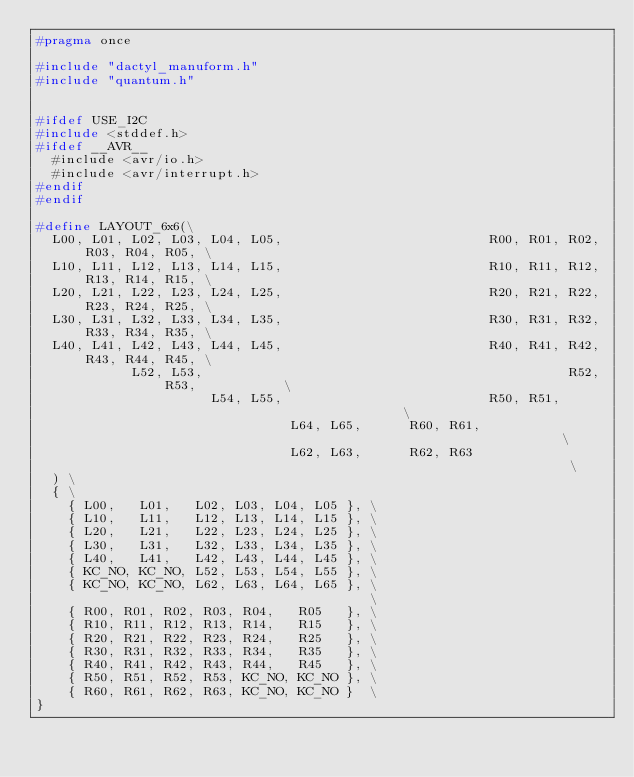<code> <loc_0><loc_0><loc_500><loc_500><_C_>#pragma once

#include "dactyl_manuform.h"
#include "quantum.h"


#ifdef USE_I2C
#include <stddef.h>
#ifdef __AVR__
  #include <avr/io.h>
  #include <avr/interrupt.h>
#endif
#endif

#define LAYOUT_6x6(\
  L00, L01, L02, L03, L04, L05,                          R00, R01, R02, R03, R04, R05, \
  L10, L11, L12, L13, L14, L15,                          R10, R11, R12, R13, R14, R15, \
  L20, L21, L22, L23, L24, L25,                          R20, R21, R22, R23, R24, R25, \
  L30, L31, L32, L33, L34, L35,                          R30, R31, R32, R33, R34, R35, \
  L40, L41, L42, L43, L44, L45,                          R40, R41, R42, R43, R44, R45, \
            L52, L53,                                              R52, R53,           \
                      L54, L55,                          R50, R51,                     \
                                L64, L65,      R60, R61,                               \
                                L62, L63,      R62, R63                                \
  ) \
  { \
    { L00,   L01,   L02, L03, L04, L05 }, \
    { L10,   L11,   L12, L13, L14, L15 }, \
    { L20,   L21,   L22, L23, L24, L25 }, \
    { L30,   L31,   L32, L33, L34, L35 }, \
    { L40,   L41,   L42, L43, L44, L45 }, \
    { KC_NO, KC_NO, L52, L53, L54, L55 }, \
    { KC_NO, KC_NO, L62, L63, L64, L65 }, \
                                          \
    { R00, R01, R02, R03, R04,   R05   }, \
    { R10, R11, R12, R13, R14,   R15   }, \
    { R20, R21, R22, R23, R24,   R25   }, \
    { R30, R31, R32, R33, R34,   R35   }, \
    { R40, R41, R42, R43, R44,   R45   }, \
    { R50, R51, R52, R53, KC_NO, KC_NO }, \
    { R60, R61, R62, R63, KC_NO, KC_NO }  \
}
</code> 